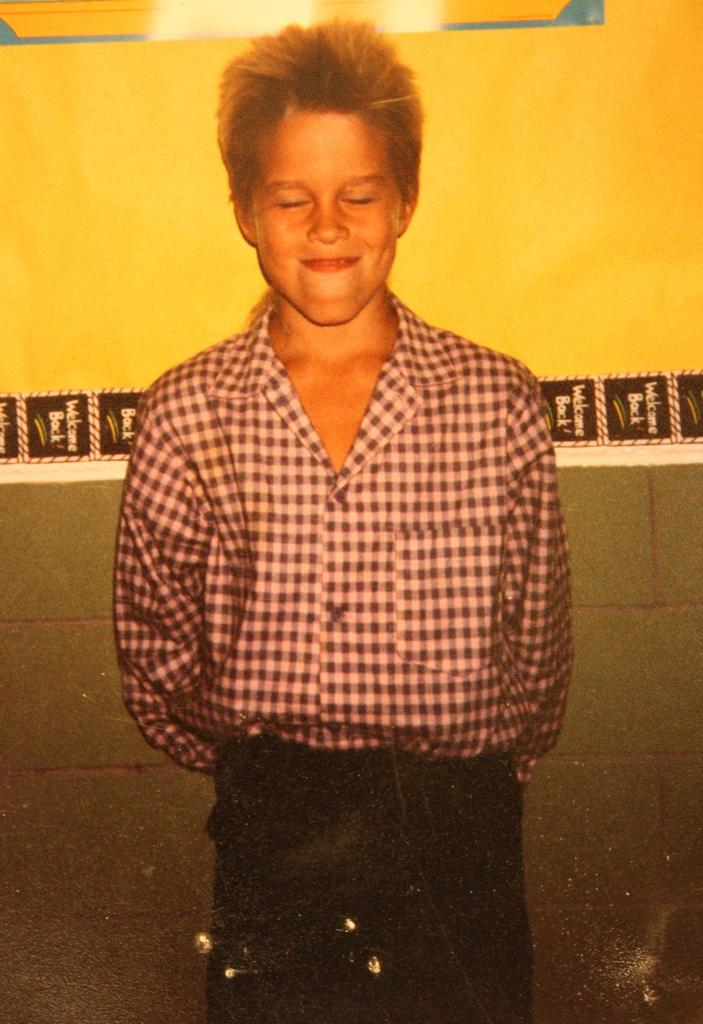Who is the main subject in the image? There is a person in the image. What is the person doing in the image? The person is standing in front of a wall, closing their eyes, and smiling. What is the person wearing in the image? The person is wearing a black shirt and a trouser. What type of ants can be seen gathering around the person's feet in the image? There are no ants present in the image; the person is standing in front of a wall. What religious event is the person attending in the image? There is no indication of a religious event in the image; the person is simply standing in front of a wall with their eyes closed and a smile on their face. 